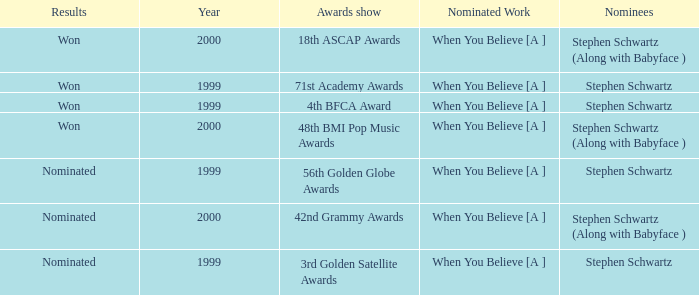Which Nominated Work won in 2000? When You Believe [A ], When You Believe [A ]. Parse the full table. {'header': ['Results', 'Year', 'Awards show', 'Nominated Work', 'Nominees'], 'rows': [['Won', '2000', '18th ASCAP Awards', 'When You Believe [A ]', 'Stephen Schwartz (Along with Babyface )'], ['Won', '1999', '71st Academy Awards', 'When You Believe [A ]', 'Stephen Schwartz'], ['Won', '1999', '4th BFCA Award', 'When You Believe [A ]', 'Stephen Schwartz'], ['Won', '2000', '48th BMI Pop Music Awards', 'When You Believe [A ]', 'Stephen Schwartz (Along with Babyface )'], ['Nominated', '1999', '56th Golden Globe Awards', 'When You Believe [A ]', 'Stephen Schwartz'], ['Nominated', '2000', '42nd Grammy Awards', 'When You Believe [A ]', 'Stephen Schwartz (Along with Babyface )'], ['Nominated', '1999', '3rd Golden Satellite Awards', 'When You Believe [A ]', 'Stephen Schwartz']]} 